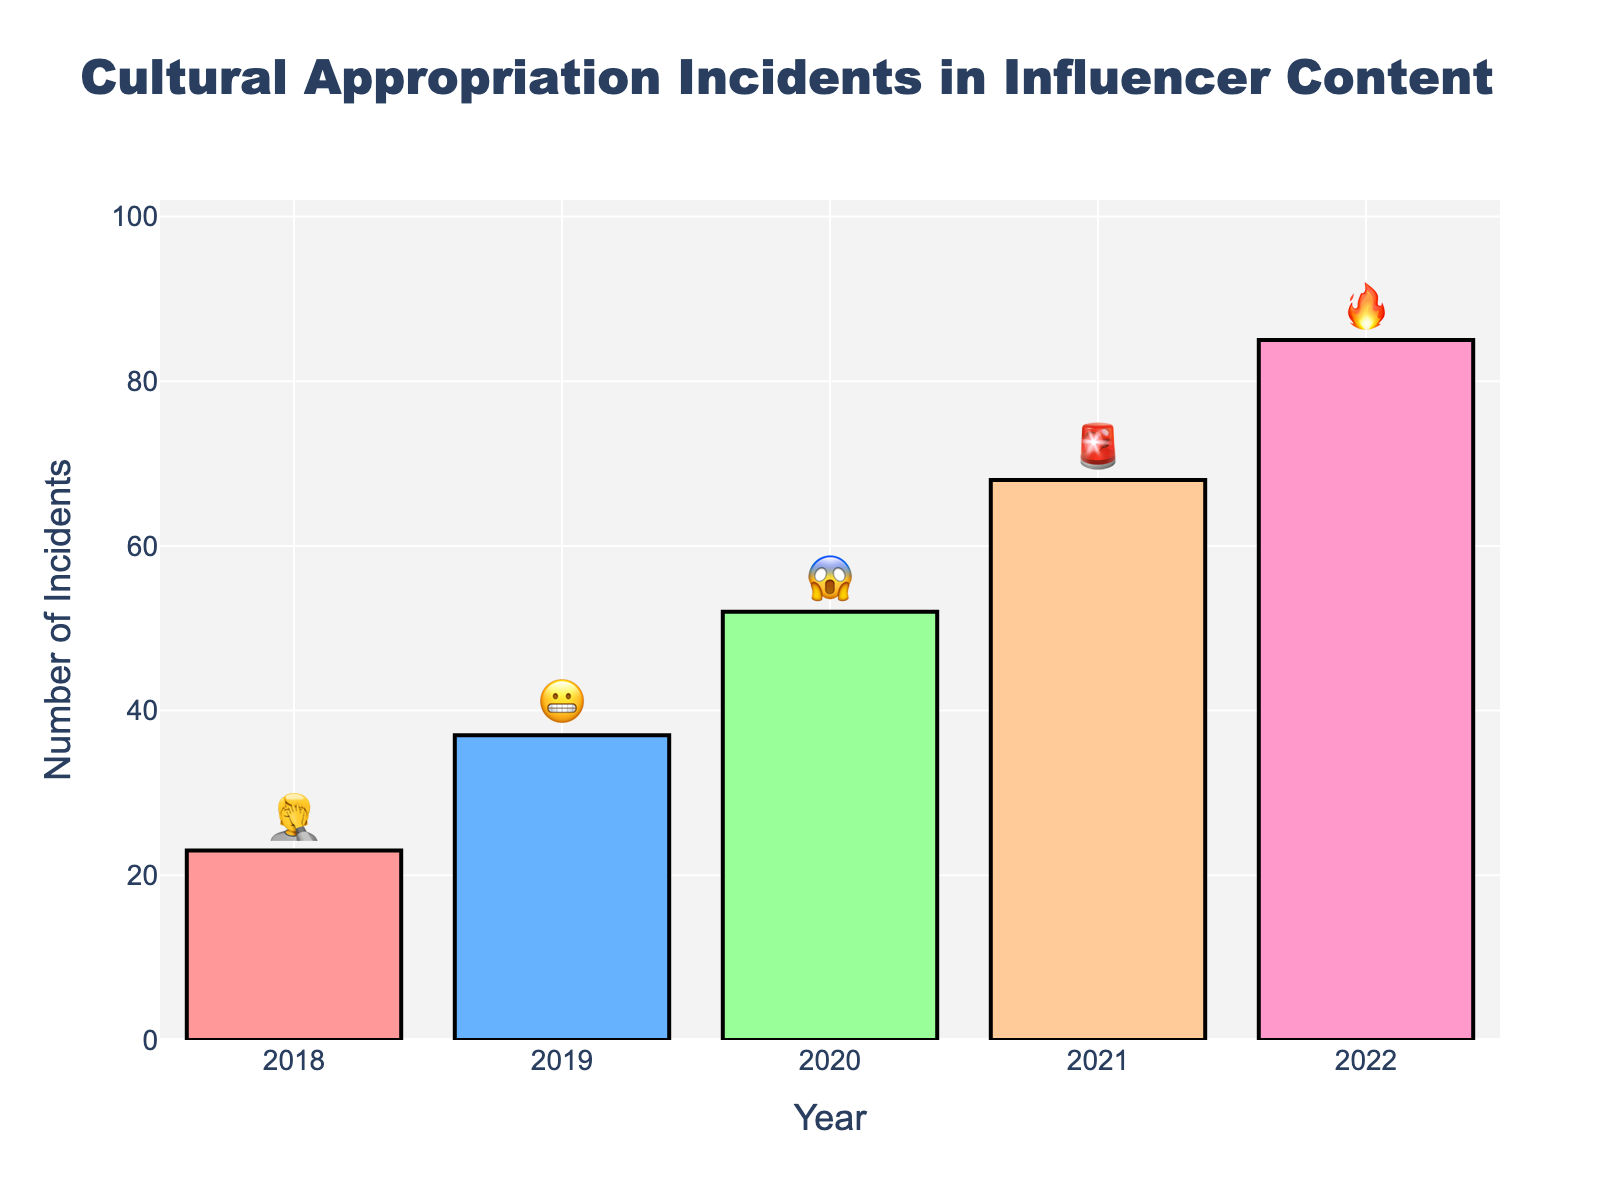What's the title of the figure? The title is usually displayed prominently at the top of the figure. In this case, you can find it clearly mentioned as "Cultural Appropriation Incidents in Influencer Content".
Answer: Cultural Appropriation Incidents in Influencer Content How many incidents were reported in 2020? To find the number of incidents in 2020, look at the bar labeled '2020' on the x-axis and check its corresponding height and text.
Answer: 52 What is the trend in the number of cultural appropriation incidents from 2018 to 2022? Observe the height of the bars from left (2018) to right (2022). The heights increase continuously, indicating an upward trend.
Answer: Increasing Which year had the highest number of incidents? Check the heights of all bars, and find that the tallest bar corresponds to the year 2022.
Answer: 2022 What is the emoji associated with the highest number of incidents? Look at the highest bar (2022) and check the text above it, which displays the emoji.
Answer: 🔥 How many more incidents were there in 2021 compared to 2019? Subtract the number of incidents in 2019 from the number in 2021. That is, 68 (2021) - 37 (2019) = 31.
Answer: 31 What is the total number of incidents reported in all years combined? Add the number of incidents for all years: 23 (2018) + 37 (2019) + 52 (2020) + 68 (2021) + 85 (2022). The total sum is 265.
Answer: 265 How many incidents were reported on average each year? Calculate the average by dividing the total number of incidents by the number of years. Total incidents are 265, spread over 5 years. So, 265 / 5 = 53.
Answer: 53 Which year saw the greatest year-over-year increase in incidents? Compare the difference in incidents between consecutive years:
  - 2019 - 2018 = 37 - 23 = 14
  - 2020 - 2019 = 52 - 37 = 15
  - 2021 - 2020 = 68 - 52 = 16
  - 2022 - 2021 = 85 - 68 = 17
  The greatest increase is between 2021 and 2022, which is 17 incidents.
Answer: 2022 What colors are used in the bars of the chart, and how do they differentiate each year? Observe the colors of the bars; each year uses a distinct color: 
  - 2018: Light pink
  - 2019: Light blue
  - 2020: Light green
  - 2021: Light orange
  - 2022: Light purple
These colors help to visually differentiate the years.
Answer: Light pink, Light blue, Light green, Light orange, Light purple 